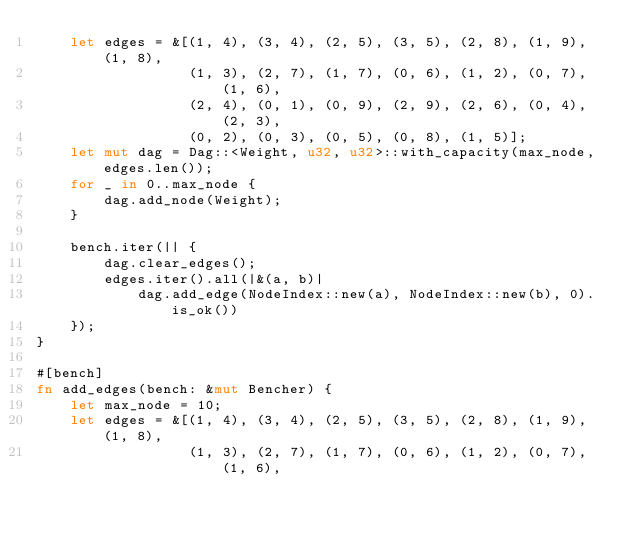<code> <loc_0><loc_0><loc_500><loc_500><_Rust_>    let edges = &[(1, 4), (3, 4), (2, 5), (3, 5), (2, 8), (1, 9), (1, 8),
                  (1, 3), (2, 7), (1, 7), (0, 6), (1, 2), (0, 7), (1, 6),
                  (2, 4), (0, 1), (0, 9), (2, 9), (2, 6), (0, 4), (2, 3),
                  (0, 2), (0, 3), (0, 5), (0, 8), (1, 5)];
    let mut dag = Dag::<Weight, u32, u32>::with_capacity(max_node, edges.len());
    for _ in 0..max_node {
        dag.add_node(Weight);
    }

    bench.iter(|| {
        dag.clear_edges();
        edges.iter().all(|&(a, b)|
            dag.add_edge(NodeIndex::new(a), NodeIndex::new(b), 0).is_ok())
    });
}

#[bench]
fn add_edges(bench: &mut Bencher) {
    let max_node = 10;
    let edges = &[(1, 4), (3, 4), (2, 5), (3, 5), (2, 8), (1, 9), (1, 8),
                  (1, 3), (2, 7), (1, 7), (0, 6), (1, 2), (0, 7), (1, 6),</code> 